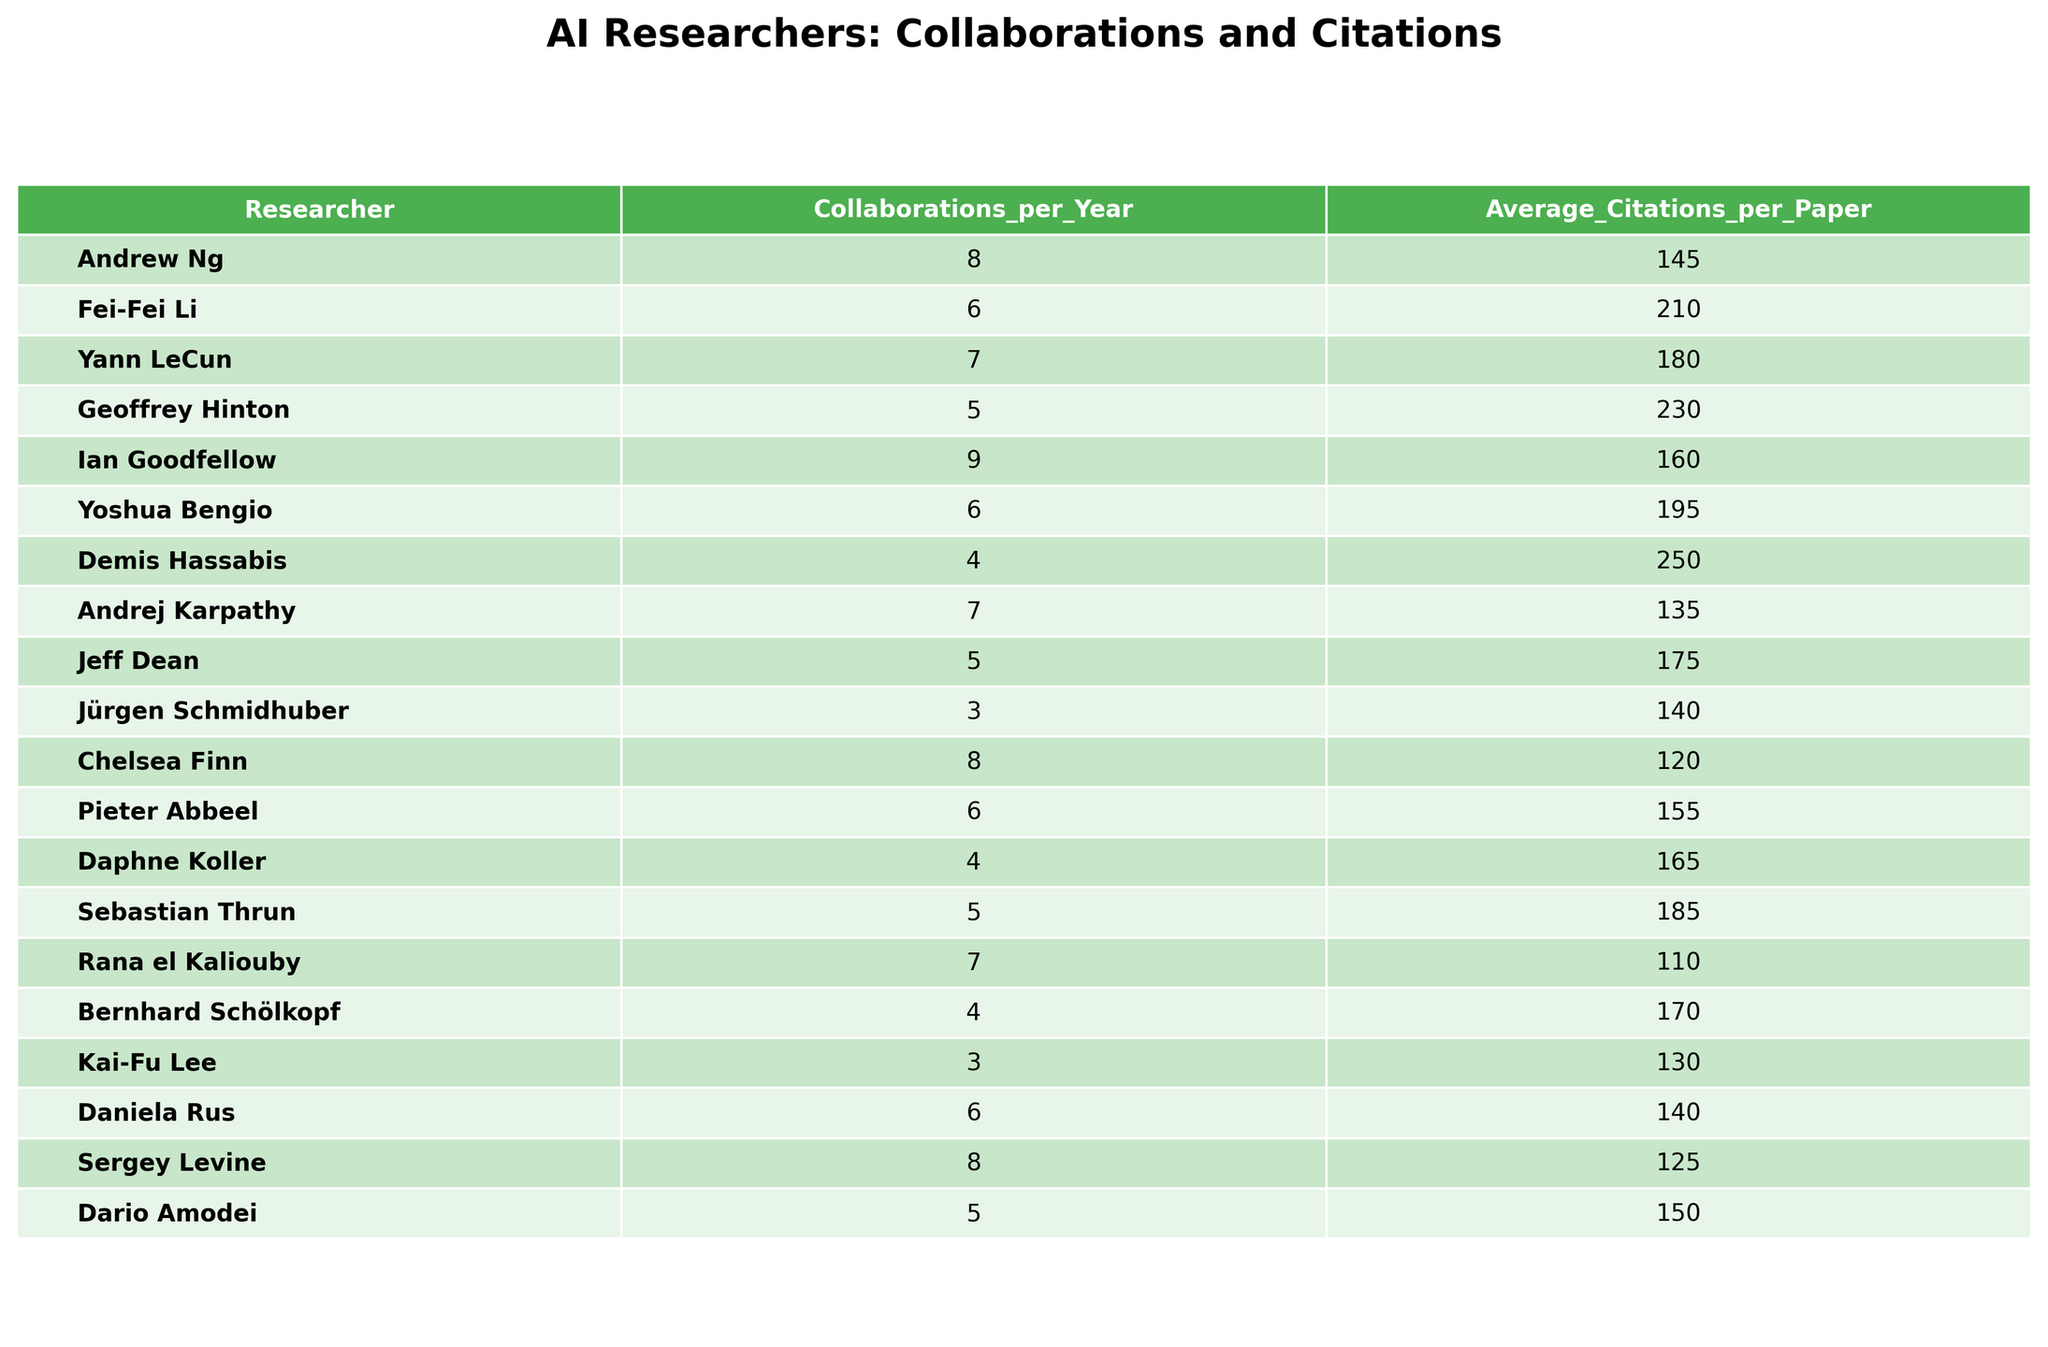What is the average number of collaborations per year among the researchers? To find the average, sum all the collaborations per year: (8 + 6 + 7 + 5 + 9 + 6 + 4 + 7 + 5 + 3 + 8 + 6 + 4 + 5 + 7 + 4 + 3 + 6 + 8 + 5) = 103. There are 20 researchers, so the average is 103 / 20 = 5.15.
Answer: 5.15 Which researcher has the highest average citations per paper? By examining the table, Geoffrey Hinton has the highest citation count of 230.
Answer: Geoffrey Hinton Is there a researcher with both high collaborations and high citations? Andrew Ng has 8 collaborations and 145 citations, while Fei-Fei Li has 6 collaborations and 210 citations. Both show a reasonable balance of collaboration and citations.
Answer: Yes What is the total number of citations of all researchers combined? Summing all average citations gives: (145 + 210 + 180 + 230 + 160 + 195 + 250 + 135 + 175 + 140 + 120 + 155 + 165 + 185 + 110 + 170 + 130 + 140 + 125 + 150) = 2815.
Answer: 2815 How many researchers have more than 7 collaborations per year? The researchers with more than 7 collaborations are Andrew Ng, Ian Goodfellow, Chelsea Finn, and Sergey Levine, totaling 4 researchers.
Answer: 4 What is the difference in average citations between the researcher with the highest and the lowest average citations? Geoffrey Hinton has the highest citations at 230, and Rana el Kaliouby has the lowest at 110. The difference in citations is 230 - 110 = 120.
Answer: 120 Do all researchers have an average citation count of at least 100? Checking the average citations: all researchers have citations above 100, making this true.
Answer: Yes Calculate the average collaborations for researchers who have more than 200 average citations. Researchers with more than 200 citations are Geoffrey Hinton (5), Fei-Fei Li (6), and Demis Hassabis (4). Their total collaborations are 5 + 6 + 4 = 15; there are 3 researchers, so the average is 15 / 3 = 5.
Answer: 5 Which two researchers have the closest values for average citations? By observing the data, Andrew Ng (145) and Jürgen Schmidhuber (140) have the closest average citations, with a difference of 5.
Answer: Andrew Ng and Jürgen Schmidhuber If you combine the collaborations of Ian Goodfellow and Yoshua Bengio, what is the total? Ian Goodfellow has 9 collaborations and Yoshua Bengio has 6. Adding these gives 9 + 6 = 15 collaborations.
Answer: 15 What proportion of the researchers has an average citation per paper greater than or equal to 180? The researchers meeting this criterion are Fei-Fei Li, Geoffrey Hinton, Ian Goodfellow, Yoshua Bengio, and Sebastian Thrun—5 out of 20. The proportion is 5 / 20 = 0.25.
Answer: 0.25 